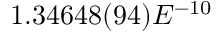<formula> <loc_0><loc_0><loc_500><loc_500>1 . 3 4 6 4 8 ( 9 4 ) E ^ { - 1 0 }</formula> 